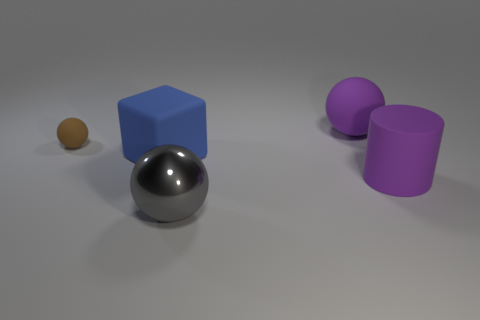Add 3 small red shiny spheres. How many objects exist? 8 Subtract all cubes. How many objects are left? 4 Subtract 0 blue balls. How many objects are left? 5 Subtract all red metal objects. Subtract all large purple matte spheres. How many objects are left? 4 Add 5 brown things. How many brown things are left? 6 Add 1 small blue rubber spheres. How many small blue rubber spheres exist? 1 